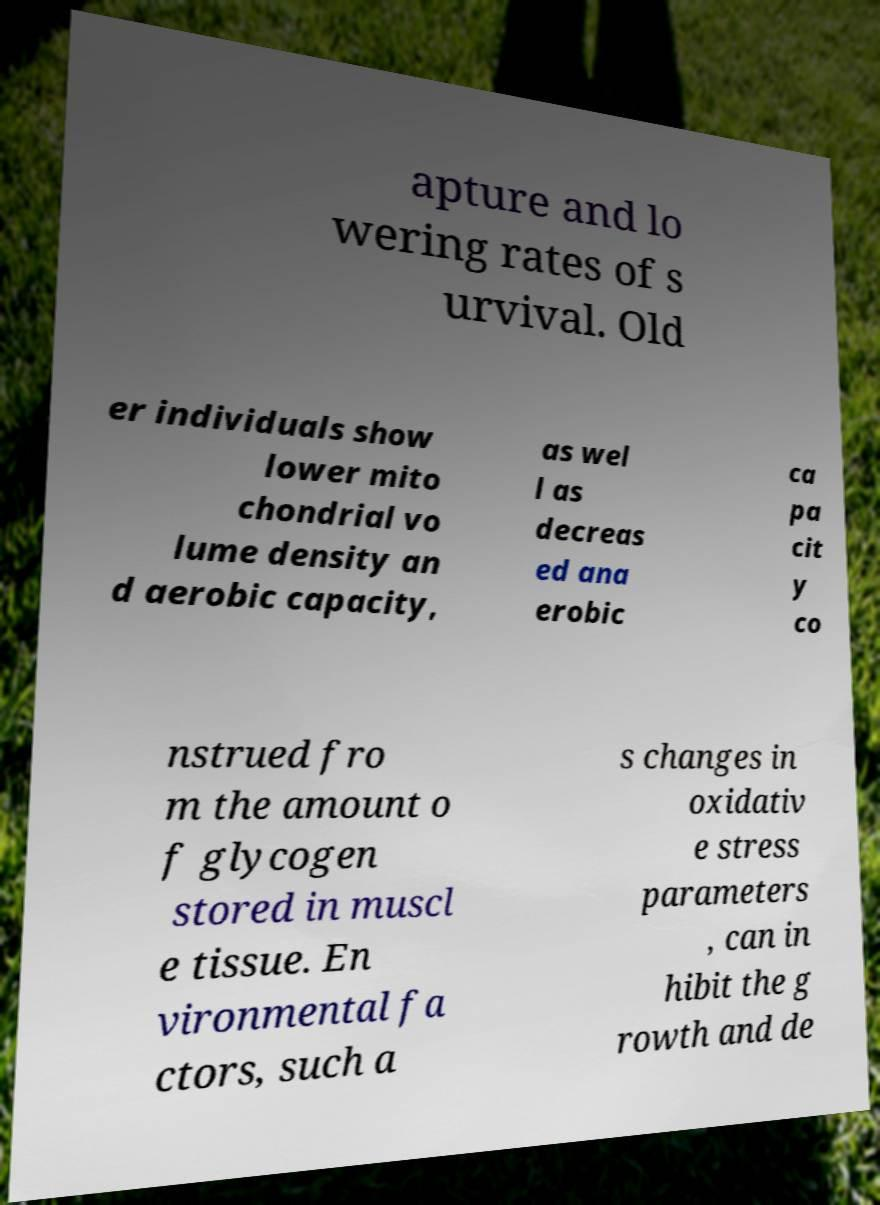Can you accurately transcribe the text from the provided image for me? apture and lo wering rates of s urvival. Old er individuals show lower mito chondrial vo lume density an d aerobic capacity, as wel l as decreas ed ana erobic ca pa cit y co nstrued fro m the amount o f glycogen stored in muscl e tissue. En vironmental fa ctors, such a s changes in oxidativ e stress parameters , can in hibit the g rowth and de 